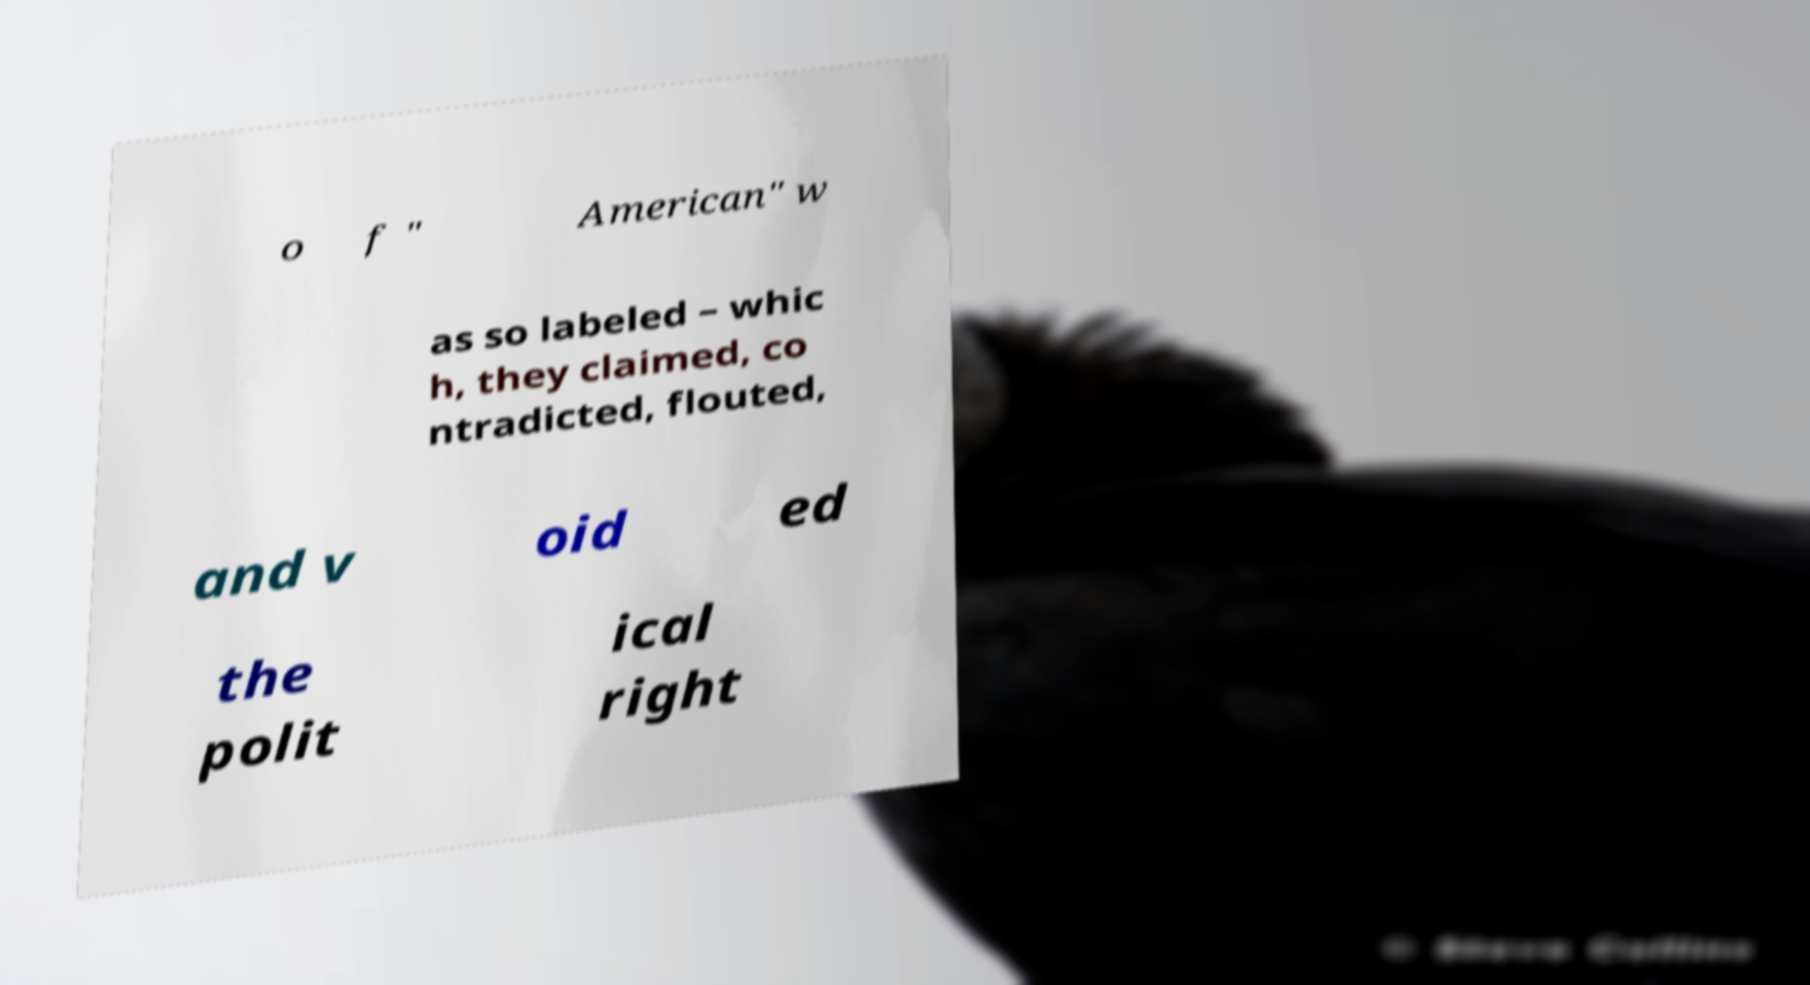Can you accurately transcribe the text from the provided image for me? o f " American" w as so labeled – whic h, they claimed, co ntradicted, flouted, and v oid ed the polit ical right 